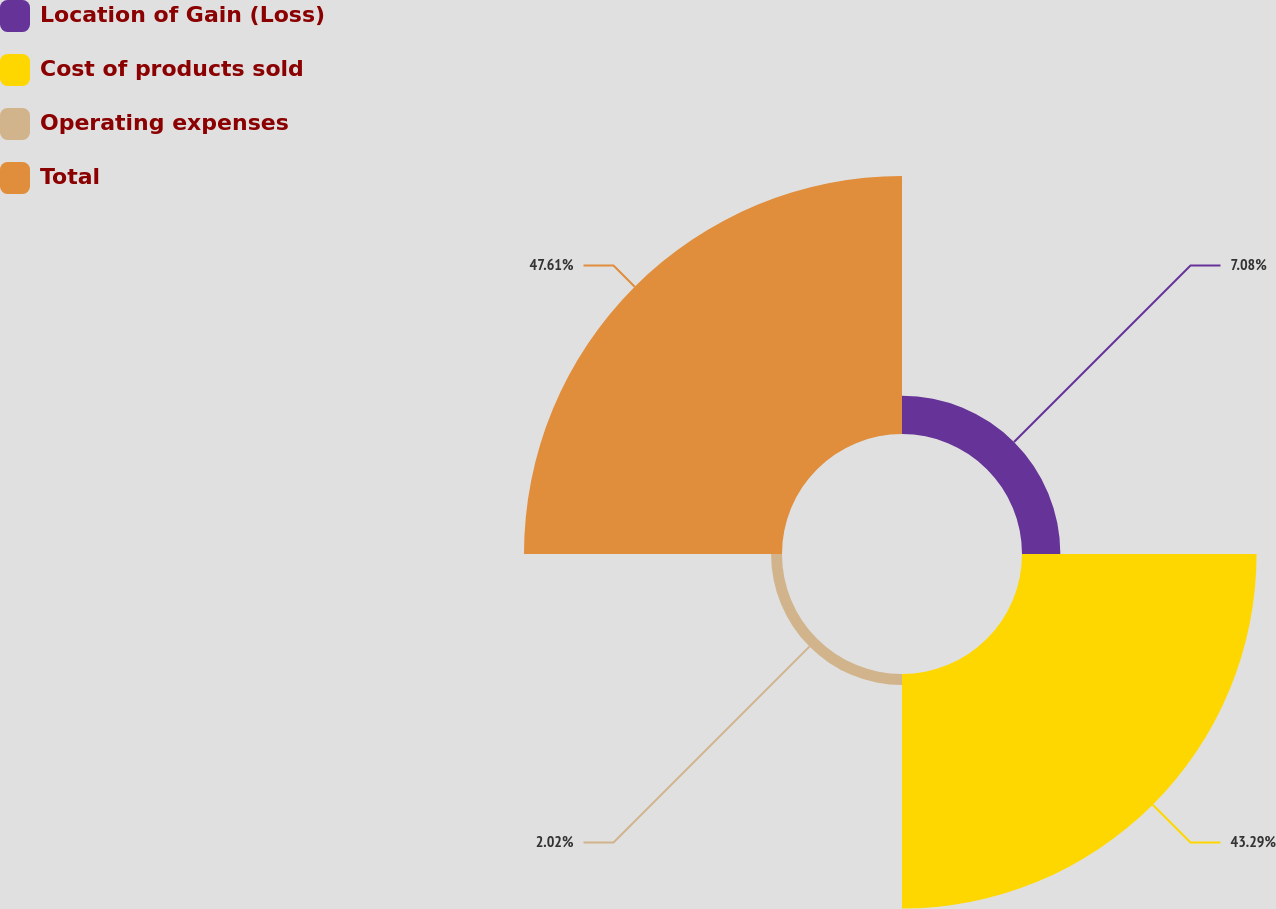<chart> <loc_0><loc_0><loc_500><loc_500><pie_chart><fcel>Location of Gain (Loss)<fcel>Cost of products sold<fcel>Operating expenses<fcel>Total<nl><fcel>7.08%<fcel>43.29%<fcel>2.02%<fcel>47.61%<nl></chart> 